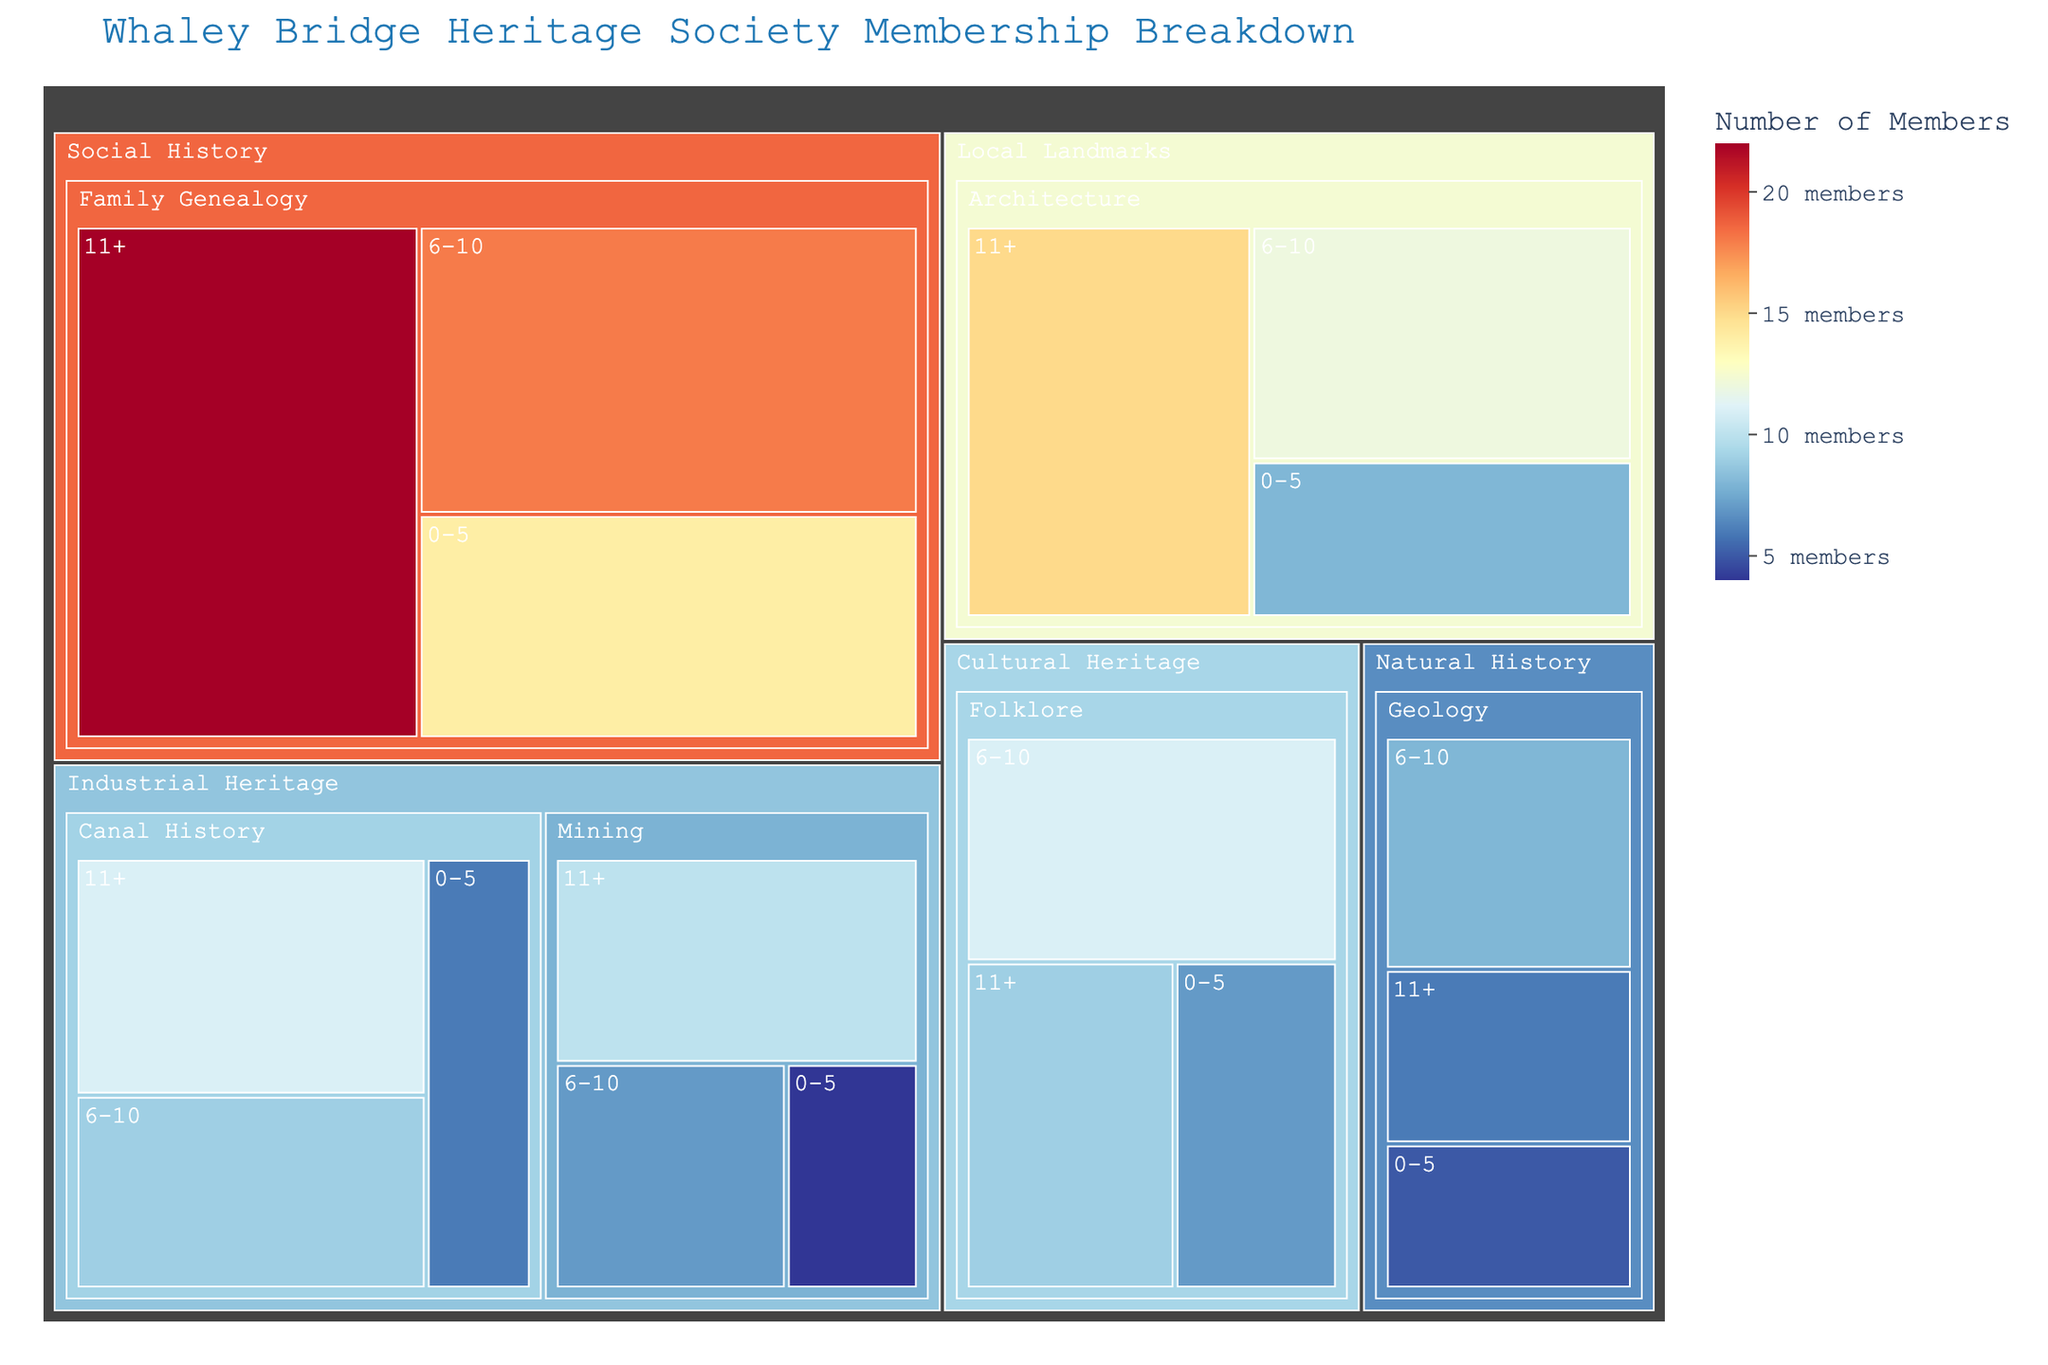what is the total number of members in the Local Landmarks area? Sum the members of all expertise levels under the Local Landmarks area: 8 + 12 + 15 = 35
Answer: 35 which expertise has the highest number of members with 11+ years of involvement? Identify the expertise with the maximum members under the 11+ years category: Family Genealogy (22) > Architecture (15) > Canal History (11) > Mining (10) > Folklore (9) > Geology (6)
Answer: Family Genealogy how many members are involved in Industrial Heritage related to Canal History? Sum the members across all years of involvement for Canal History within Industrial Heritage: 6 + 9 + 11 = 26
Answer: 26 which area has the least number of members with 0-5 years of involvement? Compare the members count across all areas for the 0-5 years of involvement category: Mining (4) < Geology (5) < Canal History (6) < Folklore (7) < Architecture (8) < Family Genealogy (14)
Answer: Mining what is the difference in the number of members between Architecture and Mining with 11+ years of involvement? Subtract the number of members in Mining from Architecture within the 11+ years involvement category: 15 - 10 = 5
Answer: 5 how does the number of members with 6-10 years of involvement in Social History compare to those in Cultural Heritage? Compare the number of members in the 6-10 years category between Social History and Cultural Heritage: Social History (18) > Cultural Heritage (11)
Answer: Social History has more members which expertise areas fall under Industrial Heritage and how are their memberships distributed by years of involvement? Identify expertise areas under Industrial Heritage and their members by years of involvement: 
- Canal History: 0-5 (6), 6-10 (9), 11+ (11)
- Mining: 0-5 (4), 6-10 (7), 11+ (10)
Answer: Canal History: 6, 9, 11; Mining: 4, 7, 10 what is the average number of members involved in Geology across all years? Calculate the average number of members by summing the members involved in Geology and dividing by the number of categories: (5 + 8 + 6) / 3 = 19 / 3 ≈ 6.33
Answer: ≈ 6.33 which expertise has the highest total number of members across all years of involvement? Sum the members across all years for each expertise and identify the highest: 
- Architecture: 8 + 12 + 15 = 35 
- Canal History: 6 + 9 + 11 = 26 
- Mining: 4 + 7 + 10 = 21
- Family Genealogy: 14 + 18 + 22 = 54 
- Geology: 5 + 8 + 6 = 19 
- Folklore: 7 + 11 + 9 = 27
Answer: Family Genealogy what proportion of the total members are involved in Cultural Heritage with any level of expertise? Calculate the proportion by summing all members involved in Cultural Heritage and dividing by the total number of members across all areas: 
- Total Cultural Heritage members: 7 + 11 + 9 = 27 
- Total members: 35 (Local Landmarks) + 26 (Canal History) + 21 (Mining) + 54 (Family Genealogy) + 19 (Geology) + 27 (Folklore) = 182
- Proportion: 27 / 182 ≈ 0.148
Answer: ≈ 0.148 